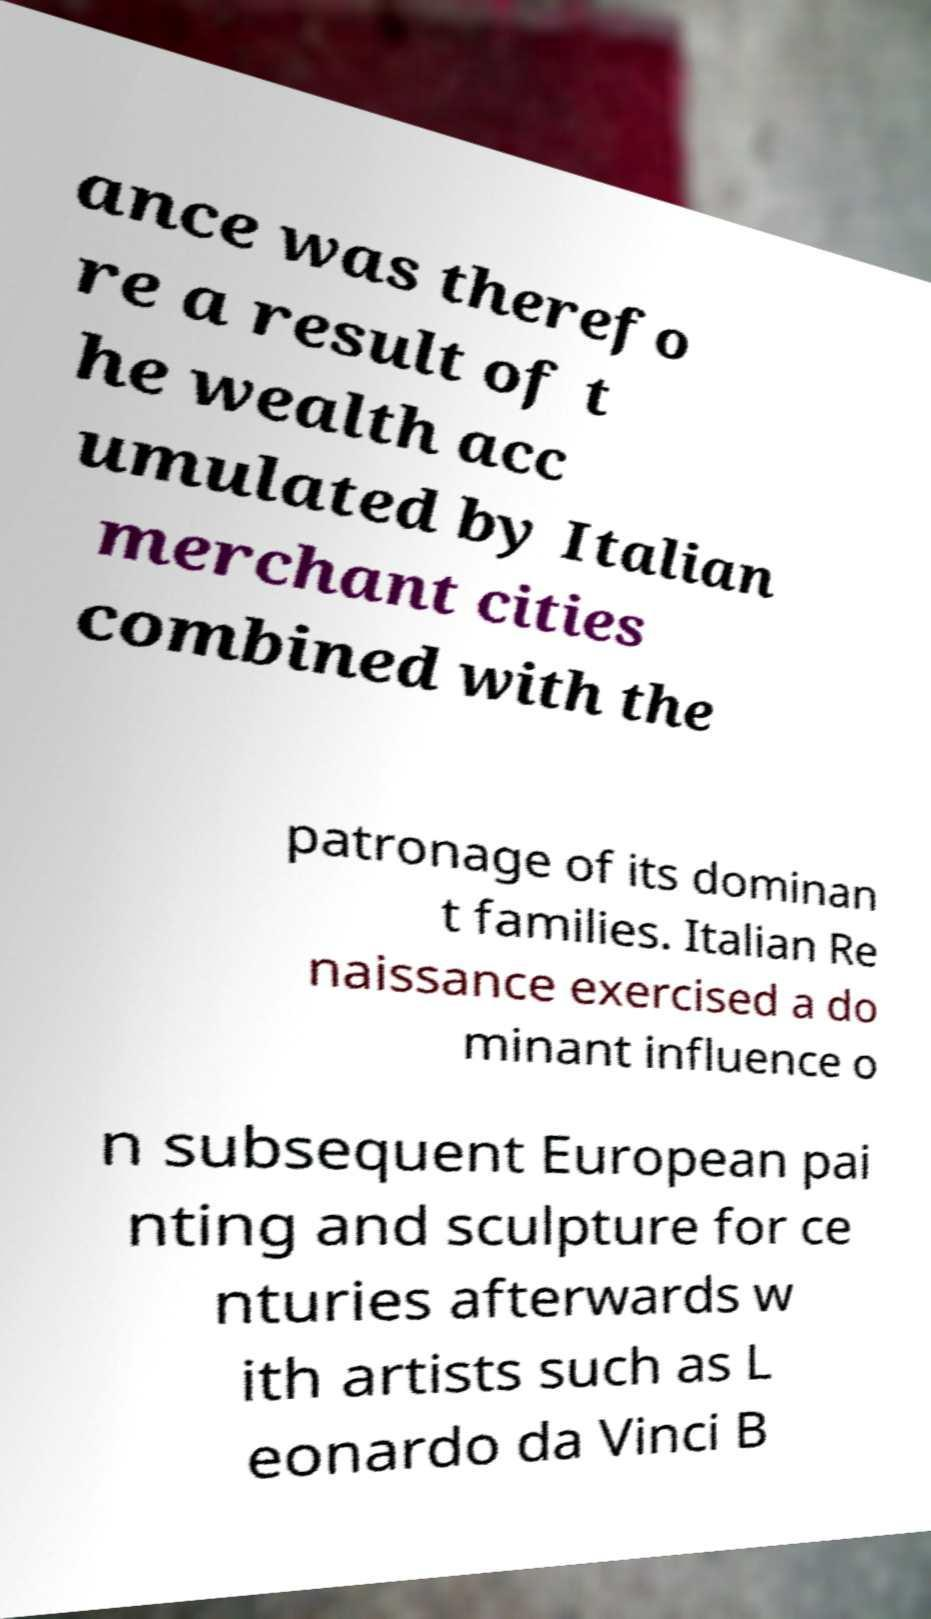For documentation purposes, I need the text within this image transcribed. Could you provide that? ance was therefo re a result of t he wealth acc umulated by Italian merchant cities combined with the patronage of its dominan t families. Italian Re naissance exercised a do minant influence o n subsequent European pai nting and sculpture for ce nturies afterwards w ith artists such as L eonardo da Vinci B 